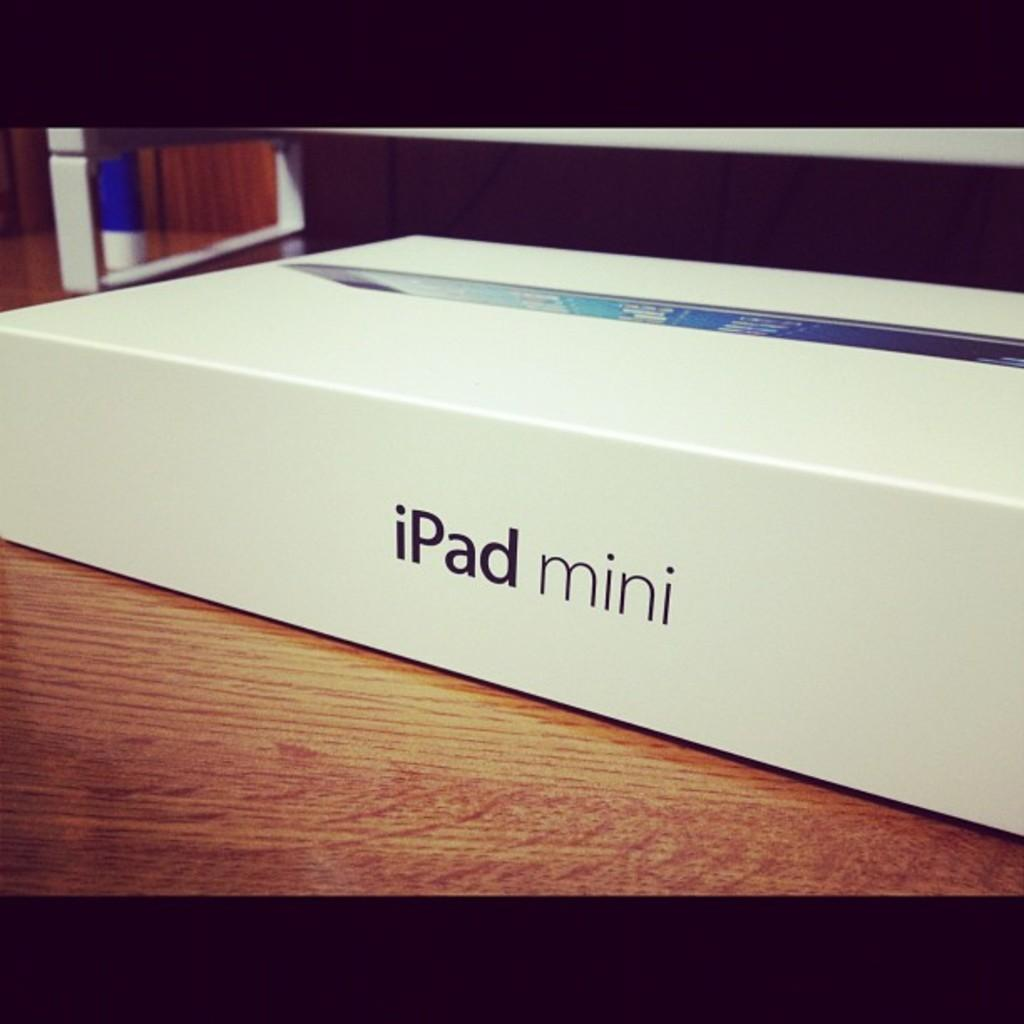What object is present in the image? There is a box in the image. On what surface is the box placed? The box is on a wooden surface. What can be found on the box? There is text on the box. What language is spoken by the plate in the image? There is no plate present in the image, and therefore no language can be attributed to it. 